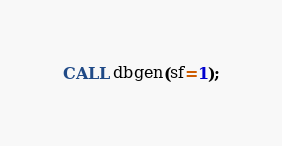<code> <loc_0><loc_0><loc_500><loc_500><_SQL_>CALL dbgen(sf=1);
</code> 